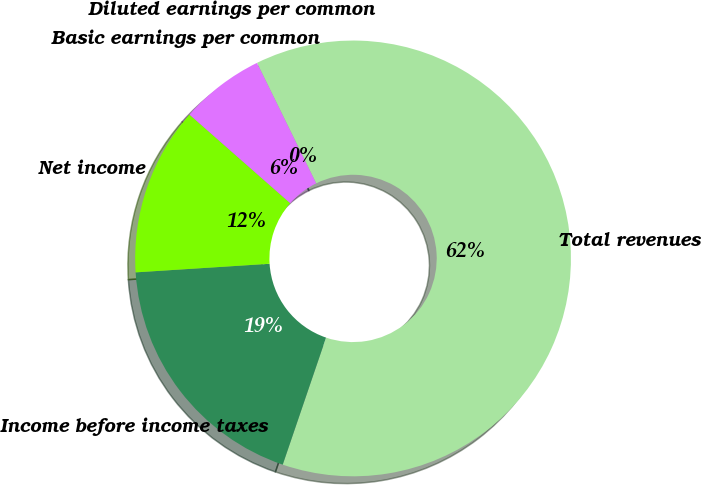Convert chart. <chart><loc_0><loc_0><loc_500><loc_500><pie_chart><fcel>Total revenues<fcel>Income before income taxes<fcel>Net income<fcel>Basic earnings per common<fcel>Diluted earnings per common<nl><fcel>62.5%<fcel>18.75%<fcel>12.5%<fcel>6.25%<fcel>0.0%<nl></chart> 